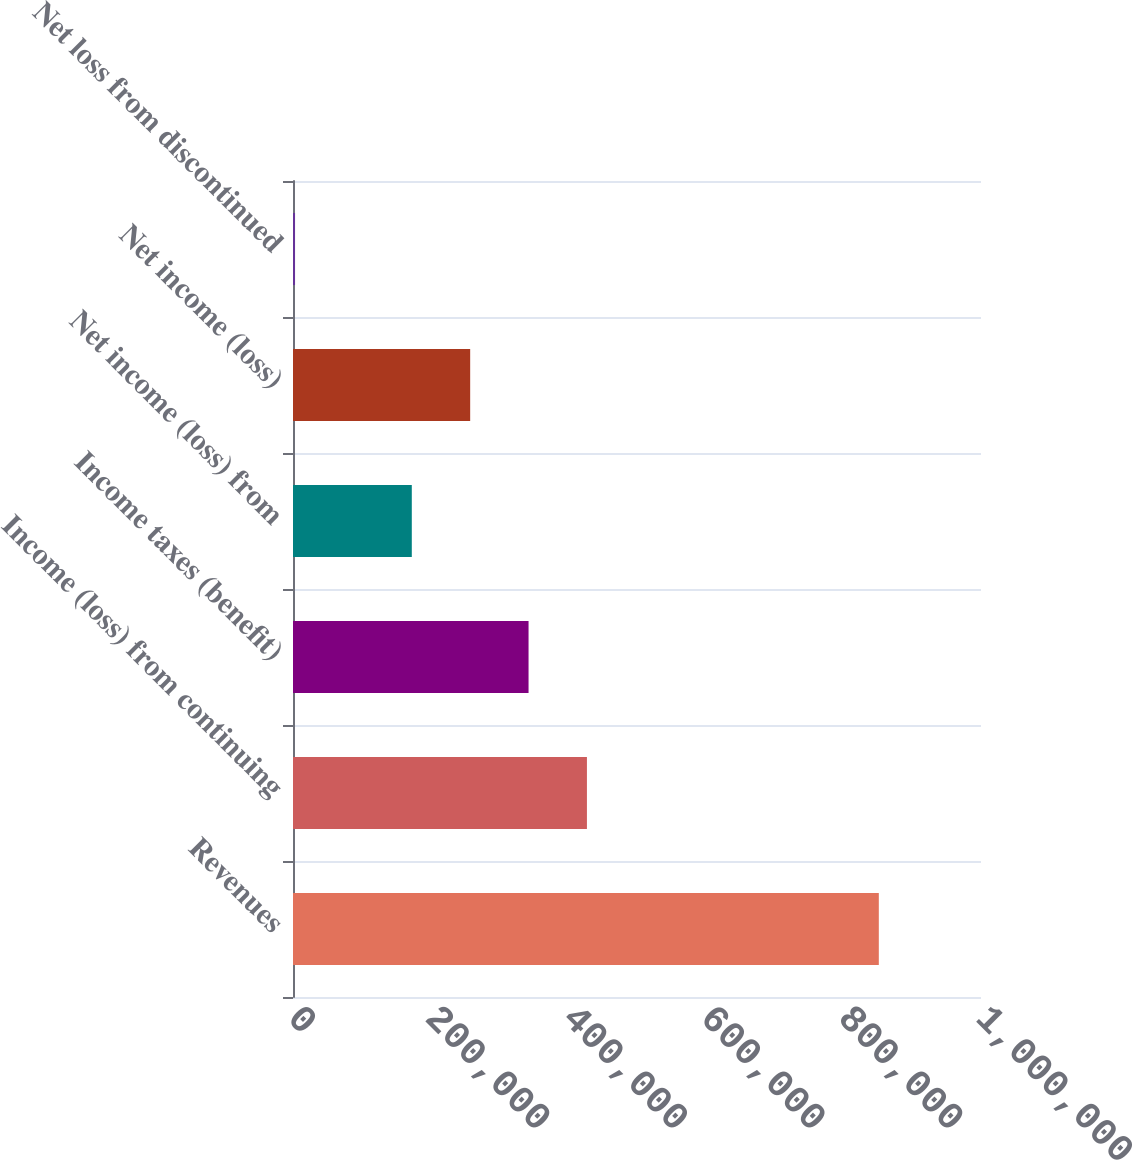Convert chart to OTSL. <chart><loc_0><loc_0><loc_500><loc_500><bar_chart><fcel>Revenues<fcel>Income (loss) from continuing<fcel>Income taxes (benefit)<fcel>Net income (loss) from<fcel>Net income (loss)<fcel>Net loss from discontinued<nl><fcel>851482<fcel>427225<fcel>342374<fcel>172671<fcel>257522<fcel>2968<nl></chart> 